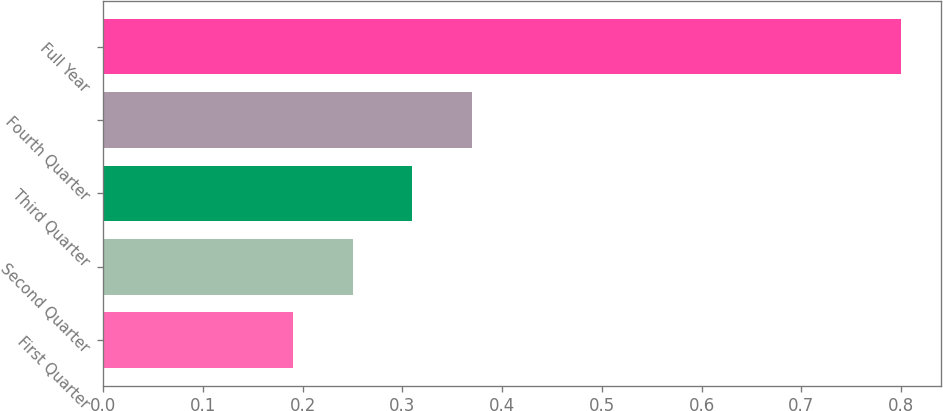<chart> <loc_0><loc_0><loc_500><loc_500><bar_chart><fcel>First Quarter<fcel>Second Quarter<fcel>Third Quarter<fcel>Fourth Quarter<fcel>Full Year<nl><fcel>0.19<fcel>0.25<fcel>0.31<fcel>0.37<fcel>0.8<nl></chart> 